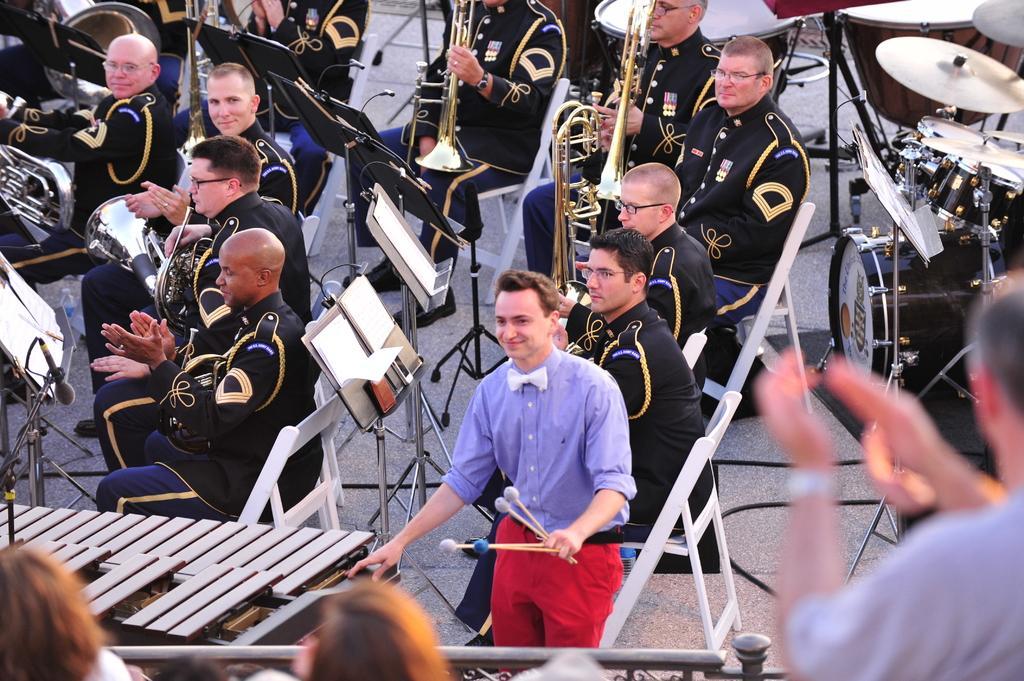Please provide a concise description of this image. This is a picture of a concert. In the picture there are many people playing different musical instrument. On the top right there are drums, in the center there are saxophone and the trumpets. In the foreground there is another musical instrument. To the right there is a man clapping. 